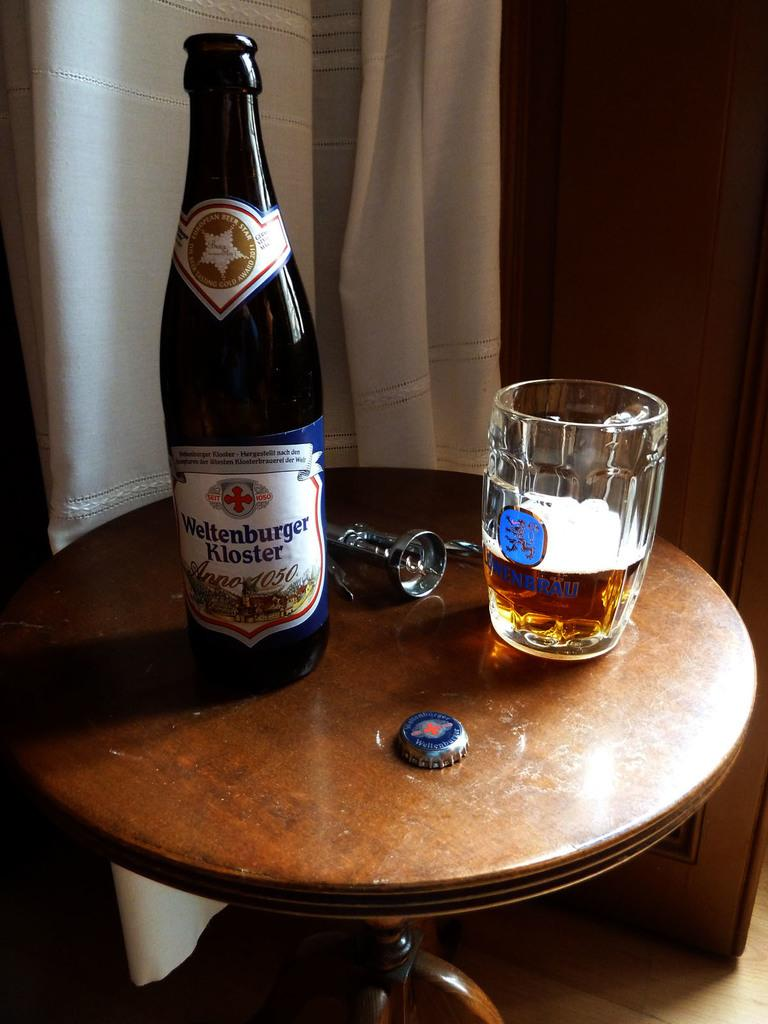What is on the bottle in the image? There is a sticker on the bottle in the image. What is in the glass in the image? There is a drink in the glass in the image. Can you describe any other items in the image? There are unspecified items in the image. What is located near the bottle in the image? There is a bottle cap in the image. What can be seen in the background of the image? There is a white-colored curtain in the background of the image. What type of nose can be seen on the stage in the image? There is no stage or nose present in the image. 